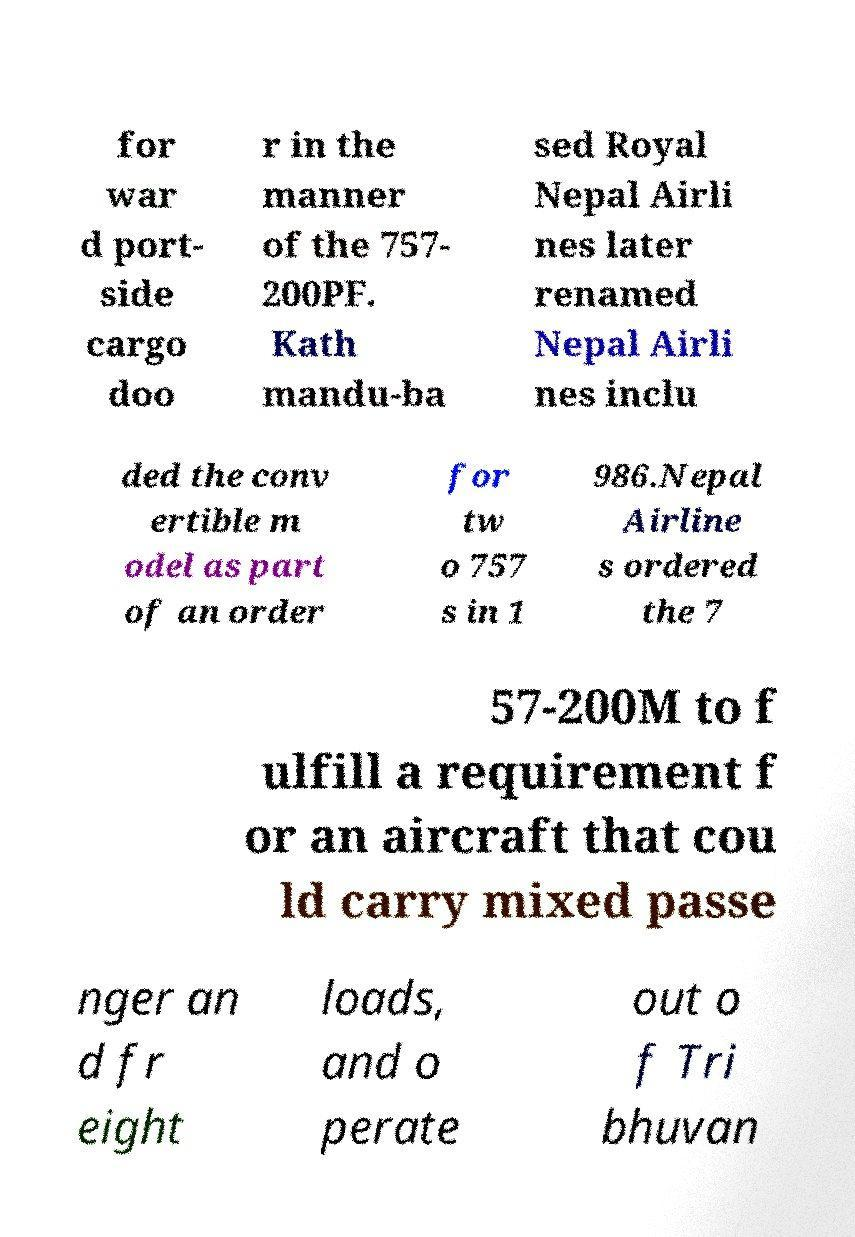What messages or text are displayed in this image? I need them in a readable, typed format. for war d port- side cargo doo r in the manner of the 757- 200PF. Kath mandu-ba sed Royal Nepal Airli nes later renamed Nepal Airli nes inclu ded the conv ertible m odel as part of an order for tw o 757 s in 1 986.Nepal Airline s ordered the 7 57-200M to f ulfill a requirement f or an aircraft that cou ld carry mixed passe nger an d fr eight loads, and o perate out o f Tri bhuvan 